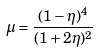Convert formula to latex. <formula><loc_0><loc_0><loc_500><loc_500>\mu = \frac { ( 1 - \eta ) ^ { 4 } } { ( 1 + 2 \eta ) ^ { 2 } }</formula> 